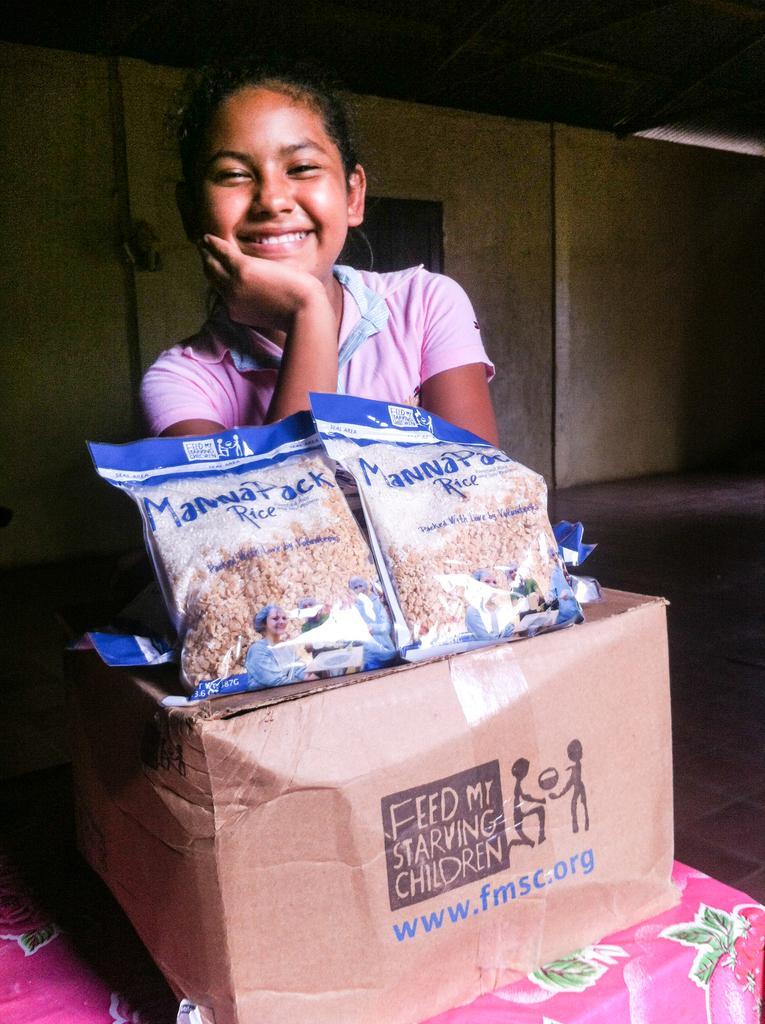Can you describe this image briefly? In the center of the image we can see a girl standing and smiling, before her there is a table and we can see a cardboard box and packs placed on the table. In the background there is a wall and a door. 